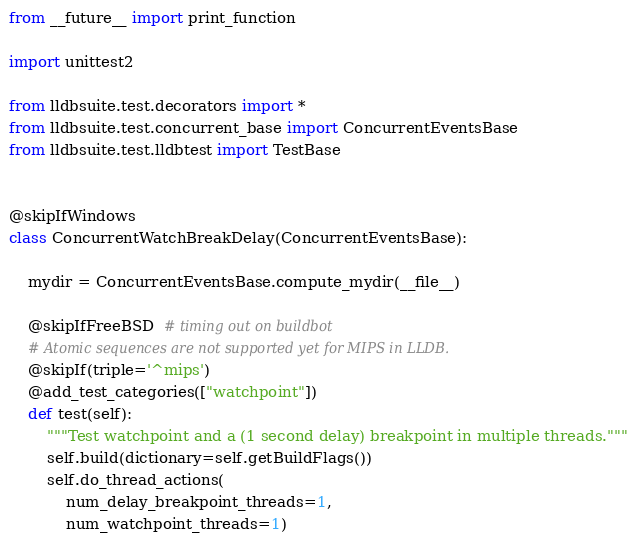<code> <loc_0><loc_0><loc_500><loc_500><_Python_>from __future__ import print_function

import unittest2

from lldbsuite.test.decorators import *
from lldbsuite.test.concurrent_base import ConcurrentEventsBase
from lldbsuite.test.lldbtest import TestBase


@skipIfWindows
class ConcurrentWatchBreakDelay(ConcurrentEventsBase):

    mydir = ConcurrentEventsBase.compute_mydir(__file__)

    @skipIfFreeBSD  # timing out on buildbot
    # Atomic sequences are not supported yet for MIPS in LLDB.
    @skipIf(triple='^mips')
    @add_test_categories(["watchpoint"])
    def test(self):
        """Test watchpoint and a (1 second delay) breakpoint in multiple threads."""
        self.build(dictionary=self.getBuildFlags())
        self.do_thread_actions(
            num_delay_breakpoint_threads=1,
            num_watchpoint_threads=1)
</code> 